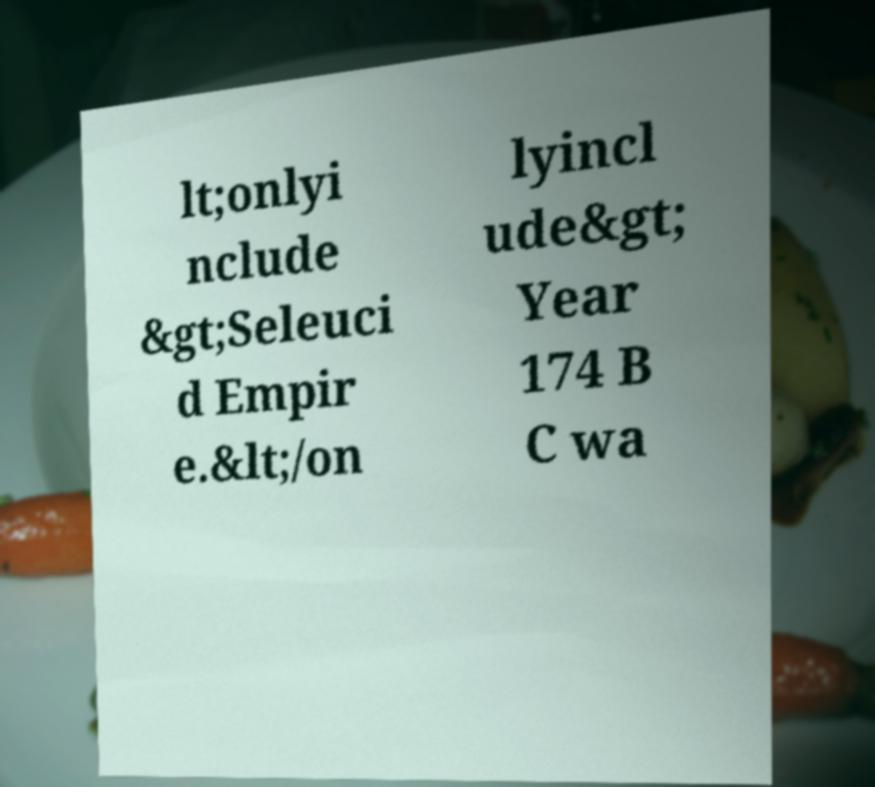Could you assist in decoding the text presented in this image and type it out clearly? lt;onlyi nclude &gt;Seleuci d Empir e.&lt;/on lyincl ude&gt; Year 174 B C wa 